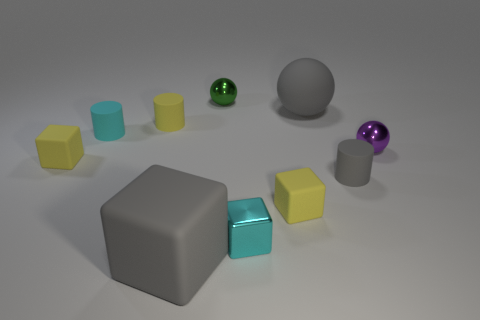Are there any other things that are the same size as the gray rubber sphere?
Your answer should be compact. Yes. Is the number of big matte objects that are behind the cyan metallic thing less than the number of green spheres in front of the gray matte sphere?
Your answer should be compact. No. How many other objects are there of the same shape as the tiny cyan metallic object?
Offer a terse response. 3. There is a matte cube on the left side of the small cyan object that is to the left of the big gray matte thing that is on the left side of the green shiny thing; what is its size?
Keep it short and to the point. Small. What number of brown things are either large cubes or small things?
Provide a succinct answer. 0. What is the shape of the big matte object that is on the left side of the metallic ball on the left side of the small cyan metal cube?
Provide a short and direct response. Cube. There is a yellow block that is to the right of the green sphere; does it have the same size as the green shiny object that is to the left of the small cyan metal object?
Make the answer very short. Yes. Is there a cyan block that has the same material as the green sphere?
Offer a terse response. Yes. There is a object that is the same color as the metallic cube; what is its size?
Make the answer very short. Small. There is a matte cylinder that is in front of the small purple metallic sphere on the right side of the big gray rubber ball; are there any tiny yellow rubber cylinders in front of it?
Provide a short and direct response. No. 